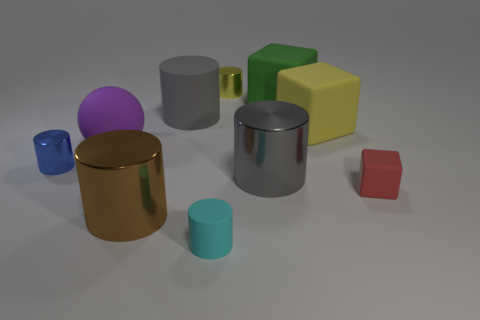Subtract all small cyan rubber cylinders. How many cylinders are left? 5 Subtract all red balls. How many gray cylinders are left? 2 Subtract 2 cylinders. How many cylinders are left? 4 Subtract all balls. How many objects are left? 9 Subtract all blue cylinders. How many cylinders are left? 5 Subtract 0 cyan spheres. How many objects are left? 10 Subtract all brown blocks. Subtract all yellow spheres. How many blocks are left? 3 Subtract all small purple matte cubes. Subtract all large green matte objects. How many objects are left? 9 Add 5 blue cylinders. How many blue cylinders are left? 6 Add 6 gray rubber cylinders. How many gray rubber cylinders exist? 7 